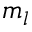<formula> <loc_0><loc_0><loc_500><loc_500>m _ { l }</formula> 